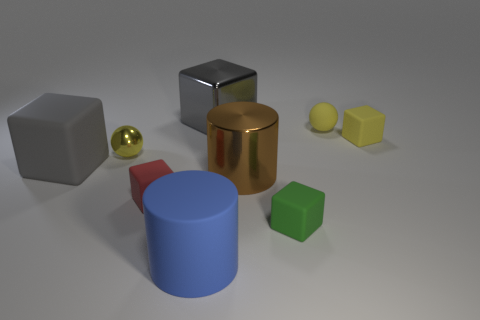Does the sphere behind the tiny metal thing have the same material as the tiny ball on the left side of the brown object? No, the sphere behind the small, shiny metallic object does not have the same material as the small, yellow ball to the left of the brown, cylindrical container. The sphere has a chrome-like, reflective finish indicative of metal, while the ball has a matte finish, suggesting a plastic or rubber composition. 